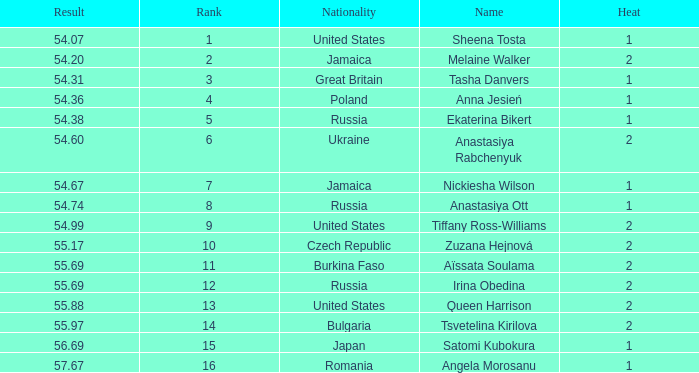Which Nationality has a Heat smaller than 2, and a Rank of 15? Japan. 